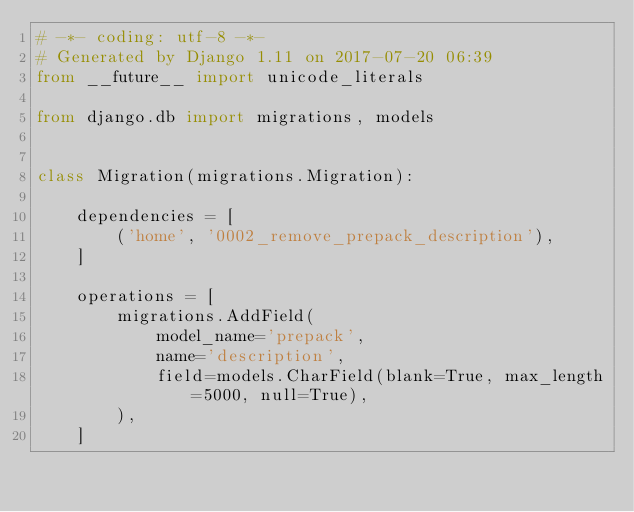Convert code to text. <code><loc_0><loc_0><loc_500><loc_500><_Python_># -*- coding: utf-8 -*-
# Generated by Django 1.11 on 2017-07-20 06:39
from __future__ import unicode_literals

from django.db import migrations, models


class Migration(migrations.Migration):

    dependencies = [
        ('home', '0002_remove_prepack_description'),
    ]

    operations = [
        migrations.AddField(
            model_name='prepack',
            name='description',
            field=models.CharField(blank=True, max_length=5000, null=True),
        ),
    ]
</code> 